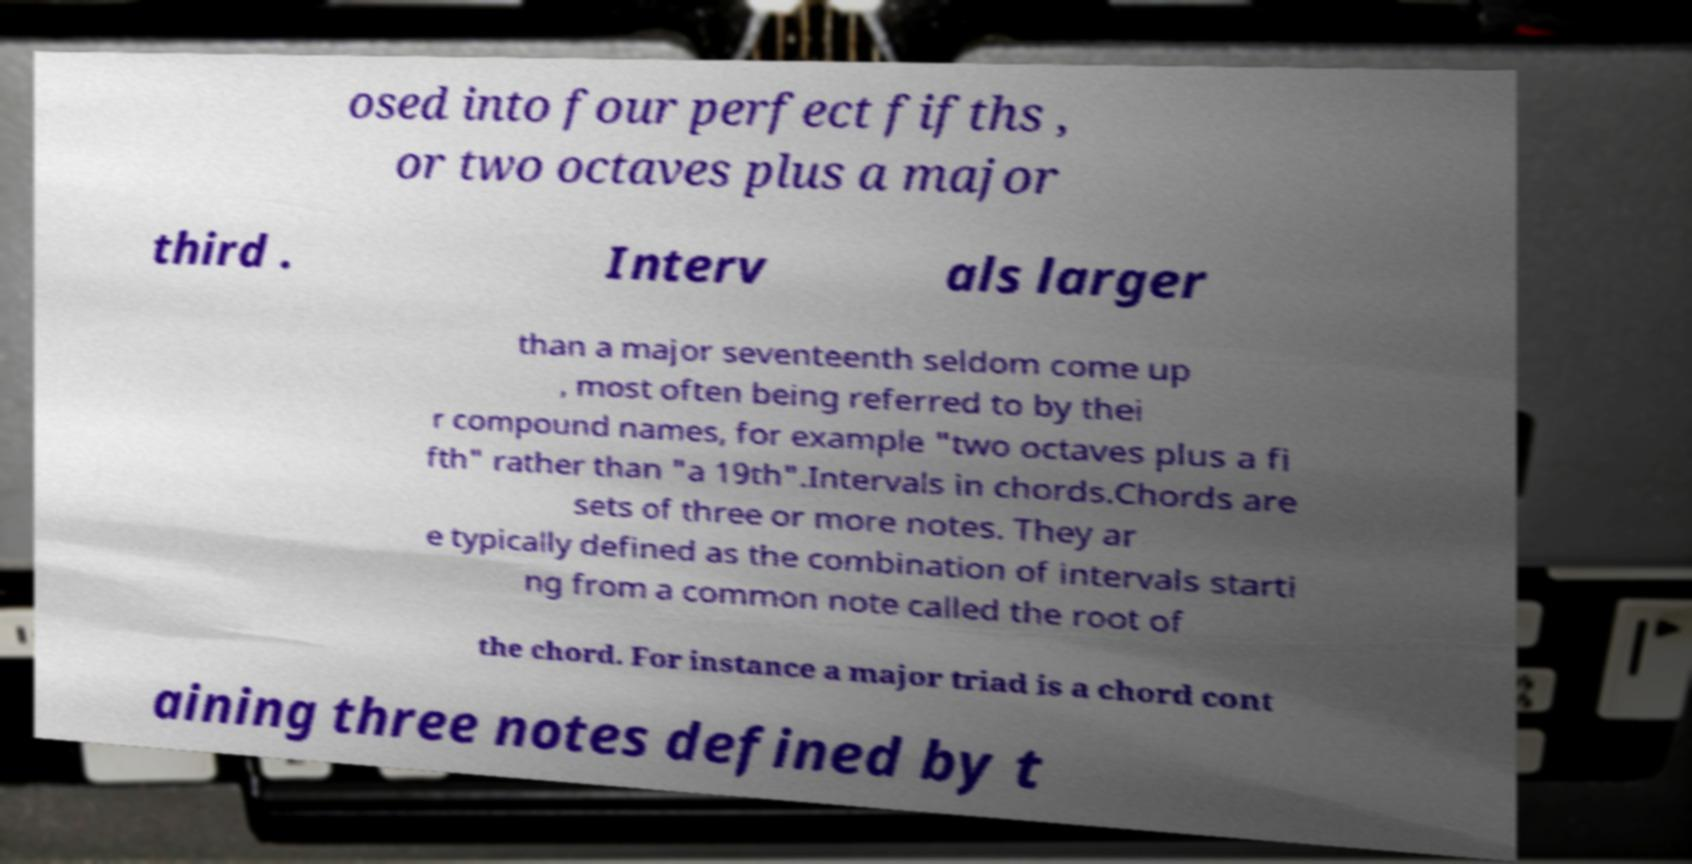Can you read and provide the text displayed in the image?This photo seems to have some interesting text. Can you extract and type it out for me? osed into four perfect fifths , or two octaves plus a major third . Interv als larger than a major seventeenth seldom come up , most often being referred to by thei r compound names, for example "two octaves plus a fi fth" rather than "a 19th".Intervals in chords.Chords are sets of three or more notes. They ar e typically defined as the combination of intervals starti ng from a common note called the root of the chord. For instance a major triad is a chord cont aining three notes defined by t 